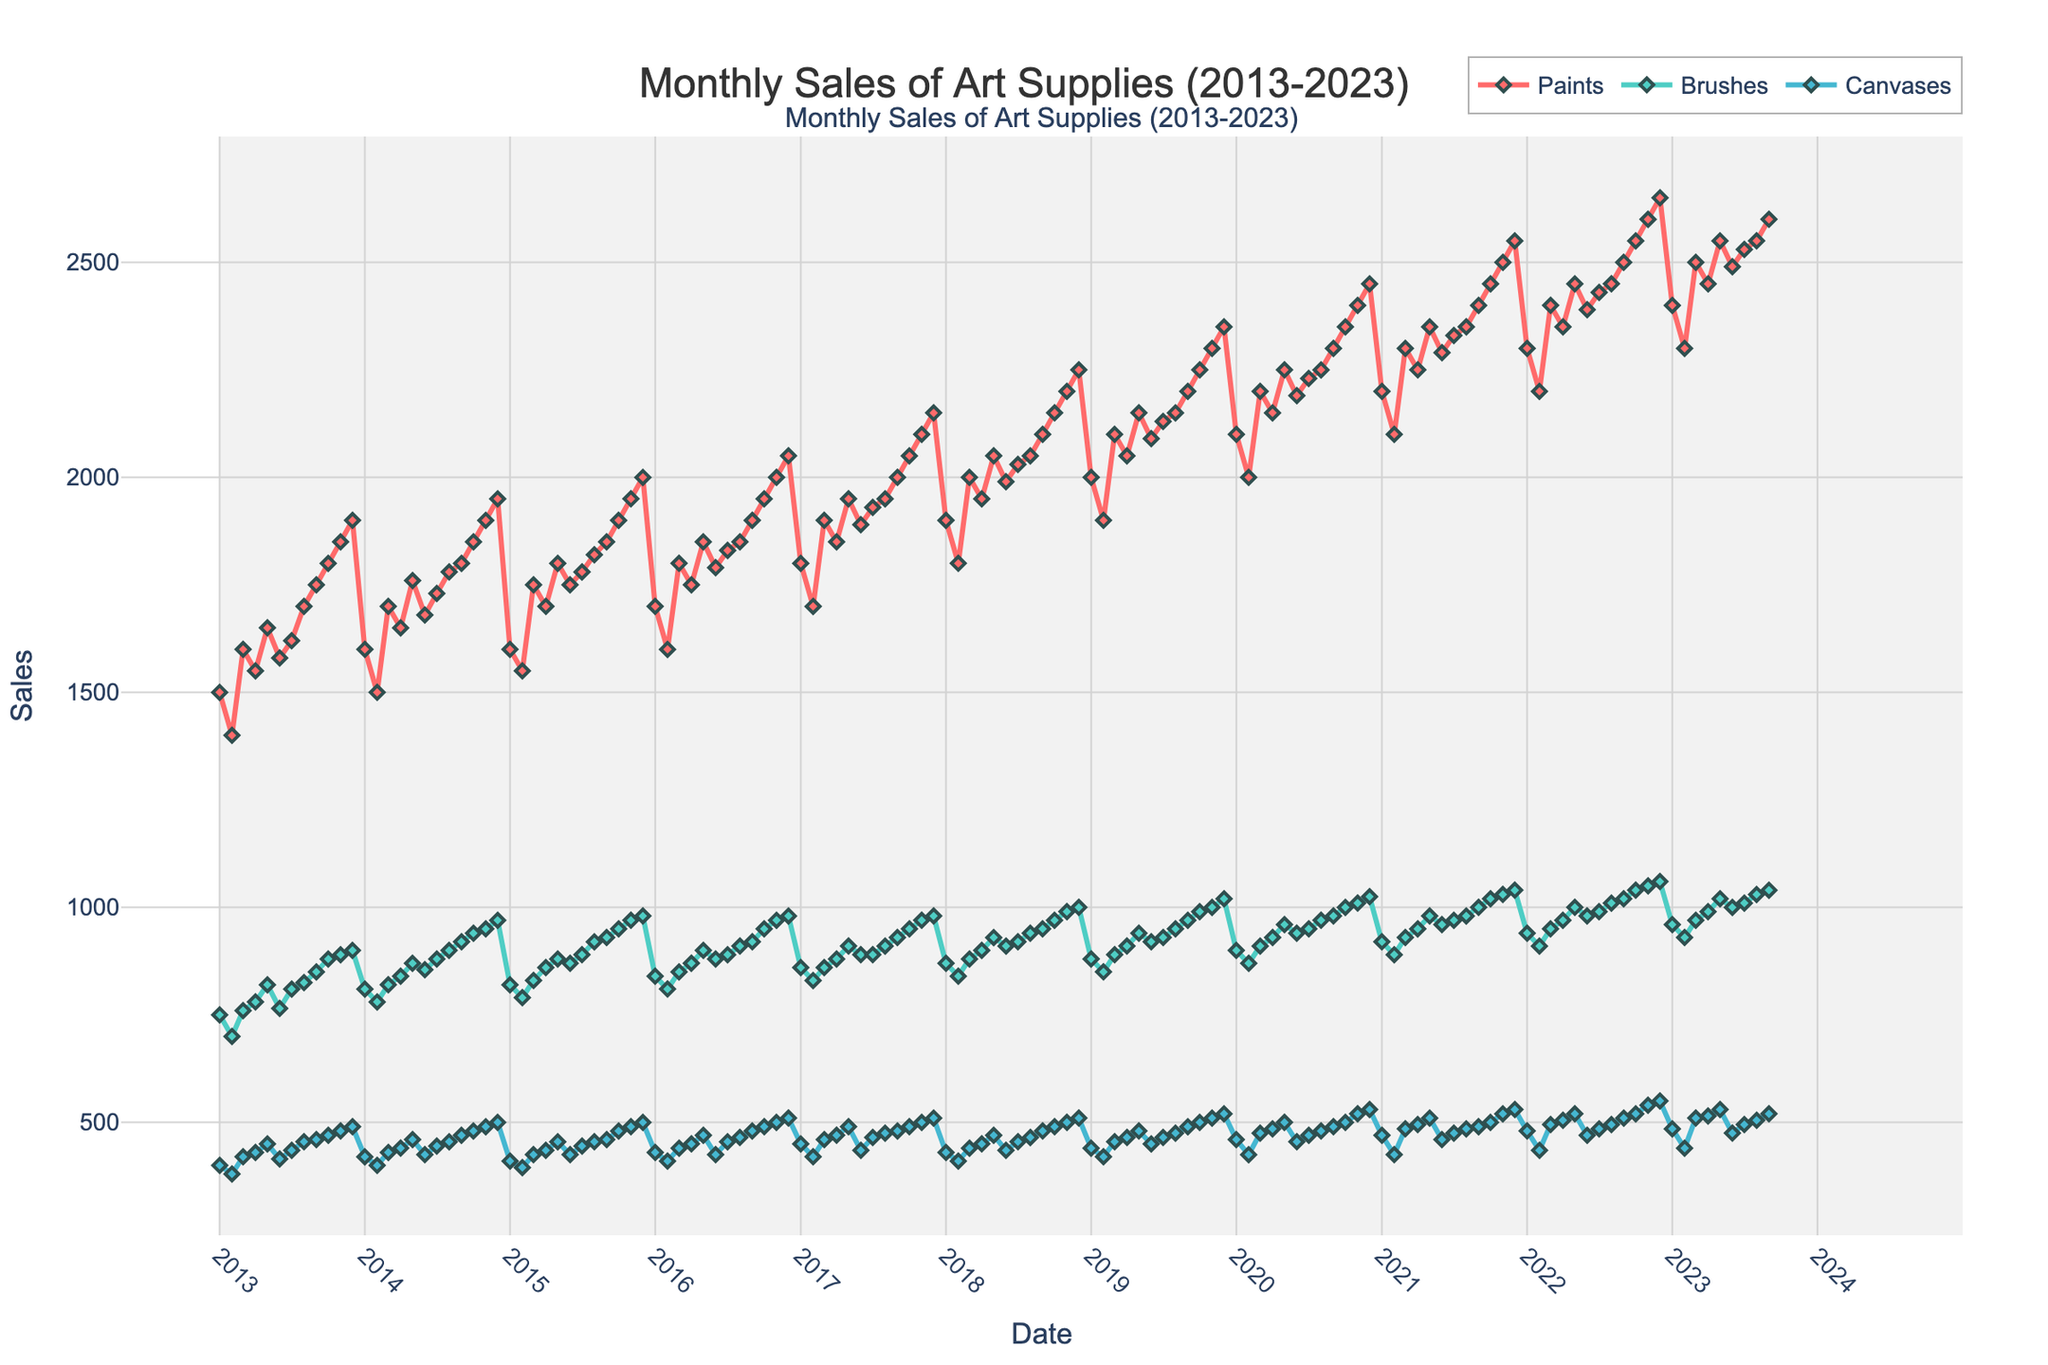How many different art supplies are tracked in the plot? The figure shows three separate traces, each representing a different art supply. These are identified as 'Paints', 'Brushes', and 'Canvases' in the legend.
Answer: 3 What is the overall trend for sales of Paints from 2013 to 2023? To identify the trend, observe the trace for Paints (typically highlighted in one color). The line appears to rise steadily over the 10-year period.
Answer: Increasing In which year did Brushes have the highest monthly sales? Look at the peaks of the Brushes trace, usually identified by color. The peak sales for Brushes is seen at the end of 2022, indicating the highest sales occurred in that year.
Answer: 2022 What was the approximate sales value of Canvases in December 2022? Locate the data point for December 2022 on the Canvases trace. The value at this point appears close to 550.
Answer: 550 Which product had the most consistent sales over the decade? Consistency can be judged by the least variability in the line. The Brushes line seems to have less fluctuation compared to Paints and Canvases.
Answer: Brushes Did any product experience a significant drop in sales? Check all traces for any sharp declines. The Paints trace shows a slight dip around early 2014, but no significant drops are observed.
Answer: No How did the sales of Paints in January 2023 compare to that in January 2013? Compare the sales values at these two points on the Paints trace. Sales in January 2023 are significantly higher than in January 2013.
Answer: Higher in 2023 Overall, which part of the year (e.g., beginning, middle, end) seems to have the highest sales volumes? Look for recurring high points across years. Typically, the end of each year (November, December) shows peaks for all products.
Answer: End of the year What year had the highest total sales across all products combined? For each year, approximate the sum of all three product sales at the peak. The year 2022 seems to have the highest combined sales judging by the peaks.
Answer: 2022 In August 2022, which product had the lowest sales? Locate August 2022 on the plot and compare the sales values of all three products. Brushes had the lowest sales value in that month.
Answer: Brushes 